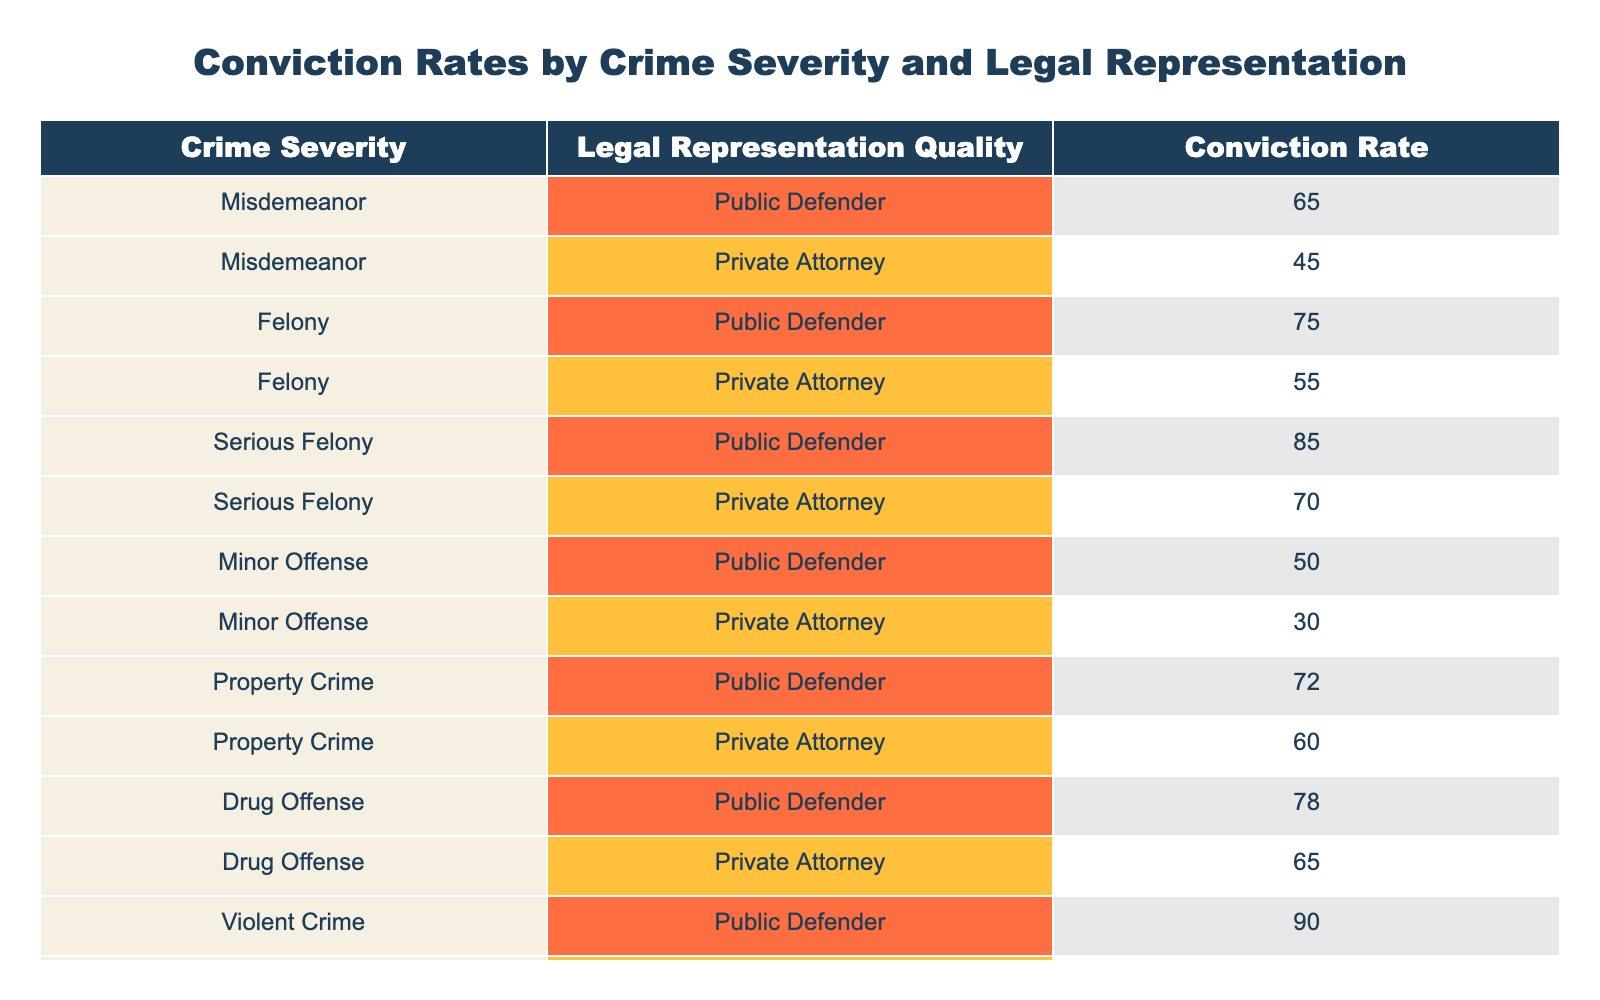What is the conviction rate for a serious felony with a private attorney? The table shows that for "Serious Felony" with "Private Attorney," the conviction rate is listed as 70%.
Answer: 70% Which legal representation has a higher conviction rate for property crimes, public defender or private attorney? The conviction rate for property crimes with a public defender is 72%, while with a private attorney it is 60%. Since 72% is greater than 60%, the public defender has a higher conviction rate.
Answer: Public defender What is the average conviction rate for misdemeanors? The conviction rates for misdemeanors are 65% and 45%. To find the average, we sum these two values (65 + 45 = 110) and divide by the number of values (110 / 2 = 55).
Answer: 55% Is the conviction rate for drug offenses higher with a public defender compared to a private attorney? The conviction rate for drug offenses with a public defender is 78%, while with a private attorney it is 65%. Since 78% is greater than 65%, the statement is true.
Answer: Yes What crime severity has the highest conviction rate with a public defender? Examining the table, the highest conviction rates with a public defender are found under "Violent Crime" at 90%. Therefore, this is the highest conviction rate listed.
Answer: Violent Crime If we consider all the felony convictions, what is the overall average conviction rate? The felony conviction rates are 75% (public defender) and 55% (private attorney) for the regular felony, and 85% (public defender) and 70% (private attorney) for the serious felony. To calculate the overall average, sum all four rates (75 + 55 + 85 + 70 = 285) and divide by the number of rates (285 / 4 = 71.25).
Answer: 71.25% Has the conviction rate for minor offenses with a public defender improved compared to those with a private attorney? The conviction rate for minor offenses with a public defender is 50%, while with a private attorney it is 30%. Since 50% is greater than 30%, the conviction rate with a public defender is indeed improved compared to the private attorney.
Answer: Yes Which type of legal representation has a consistent lower conviction rate across all types of crime severity? By analyzing the conviction rates for both public defenders and private attorneys across all crime severities, it's determined that private attorneys have a lower conviction rate than public defenders for every listed crime type.
Answer: Private Attorney What is the difference in conviction rates between serious felonies with a public defender and drug offenses with a private attorney? The conviction rate for serious felonies with a public defender is 85%, and for drug offenses with a private attorney, it is 65%. The difference is calculated as 85 - 65 = 20.
Answer: 20 